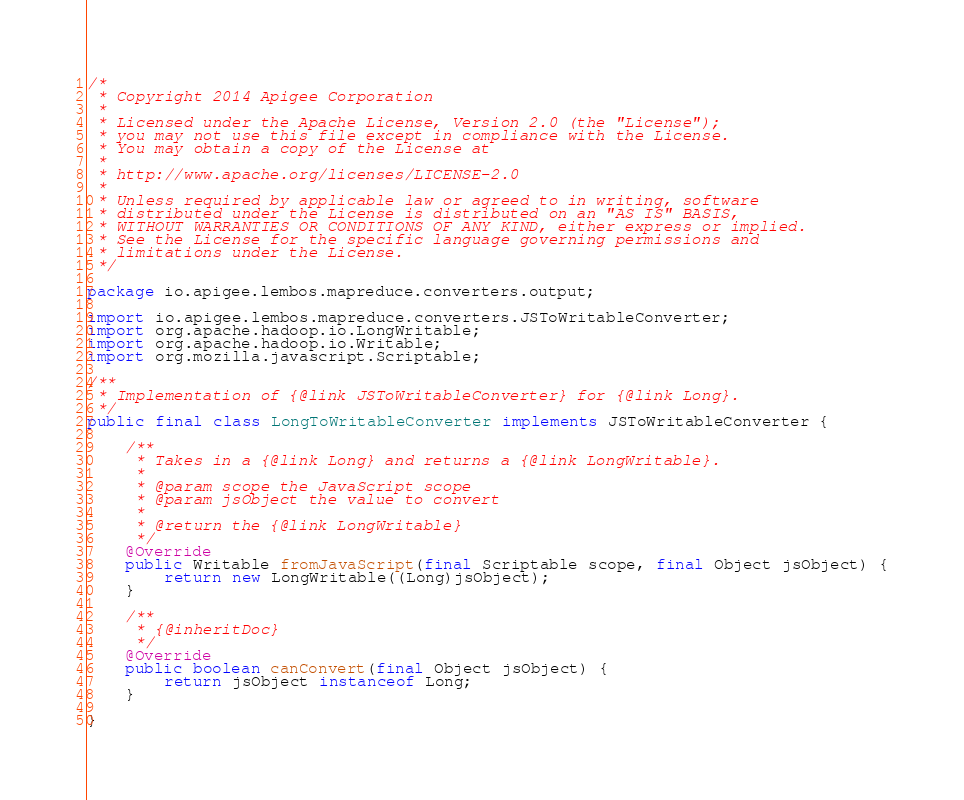<code> <loc_0><loc_0><loc_500><loc_500><_Java_>/*
 * Copyright 2014 Apigee Corporation
 *
 * Licensed under the Apache License, Version 2.0 (the "License");
 * you may not use this file except in compliance with the License.
 * You may obtain a copy of the License at
 *
 * http://www.apache.org/licenses/LICENSE-2.0
 *
 * Unless required by applicable law or agreed to in writing, software
 * distributed under the License is distributed on an "AS IS" BASIS,
 * WITHOUT WARRANTIES OR CONDITIONS OF ANY KIND, either express or implied.
 * See the License for the specific language governing permissions and
 * limitations under the License.
 */

package io.apigee.lembos.mapreduce.converters.output;

import io.apigee.lembos.mapreduce.converters.JSToWritableConverter;
import org.apache.hadoop.io.LongWritable;
import org.apache.hadoop.io.Writable;
import org.mozilla.javascript.Scriptable;

/**
 * Implementation of {@link JSToWritableConverter} for {@link Long}.
 */
public final class LongToWritableConverter implements JSToWritableConverter {

    /**
     * Takes in a {@link Long} and returns a {@link LongWritable}.
     *
     * @param scope the JavaScript scope
     * @param jsObject the value to convert
     *
     * @return the {@link LongWritable}
     */
    @Override
    public Writable fromJavaScript(final Scriptable scope, final Object jsObject) {
        return new LongWritable((Long)jsObject);
    }

    /**
     * {@inheritDoc}
     */
    @Override
    public boolean canConvert(final Object jsObject) {
        return jsObject instanceof Long;
    }

}
</code> 